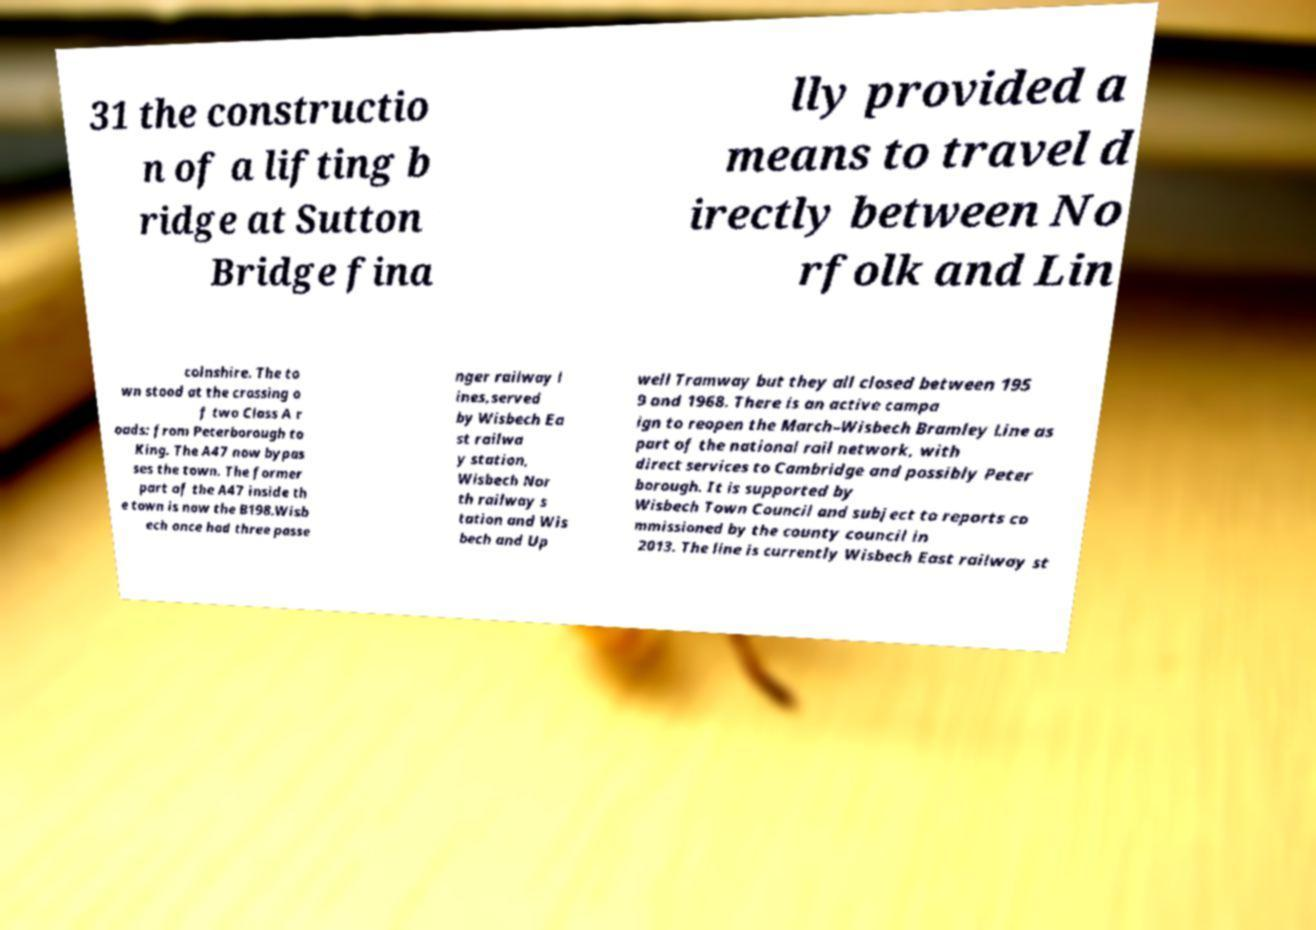Please identify and transcribe the text found in this image. 31 the constructio n of a lifting b ridge at Sutton Bridge fina lly provided a means to travel d irectly between No rfolk and Lin colnshire. The to wn stood at the crossing o f two Class A r oads: from Peterborough to King. The A47 now bypas ses the town. The former part of the A47 inside th e town is now the B198.Wisb ech once had three passe nger railway l ines,served by Wisbech Ea st railwa y station, Wisbech Nor th railway s tation and Wis bech and Up well Tramway but they all closed between 195 9 and 1968. There is an active campa ign to reopen the March–Wisbech Bramley Line as part of the national rail network, with direct services to Cambridge and possibly Peter borough. It is supported by Wisbech Town Council and subject to reports co mmissioned by the county council in 2013. The line is currently Wisbech East railway st 